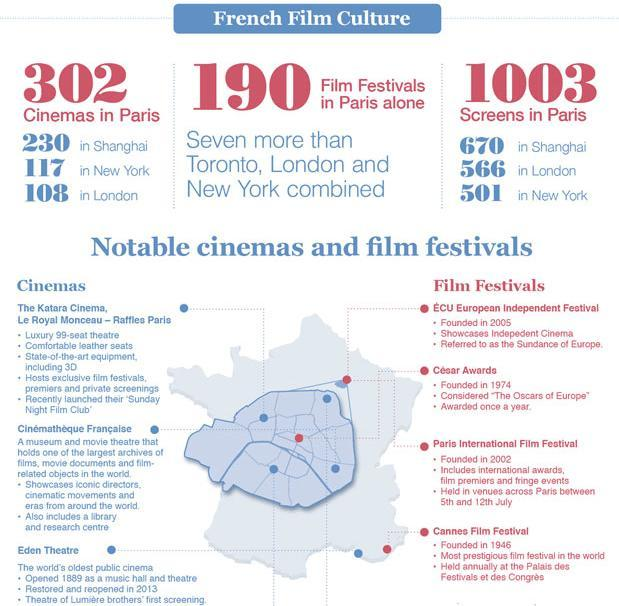Which is the most recent film festival to have been founded among the listed ones?
Answer the question with a short phrase. ECU European Independent Festival Which film festival was founded before 1950? Cannes Film Festival Which city has highest cinemas after Paris? Shanghai 